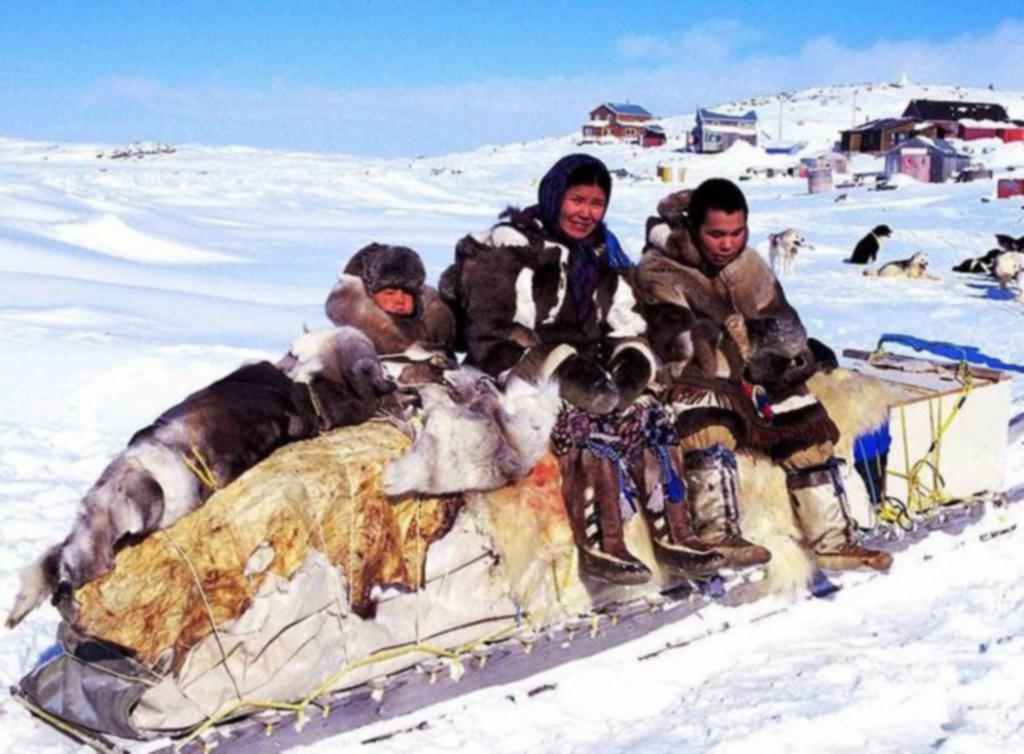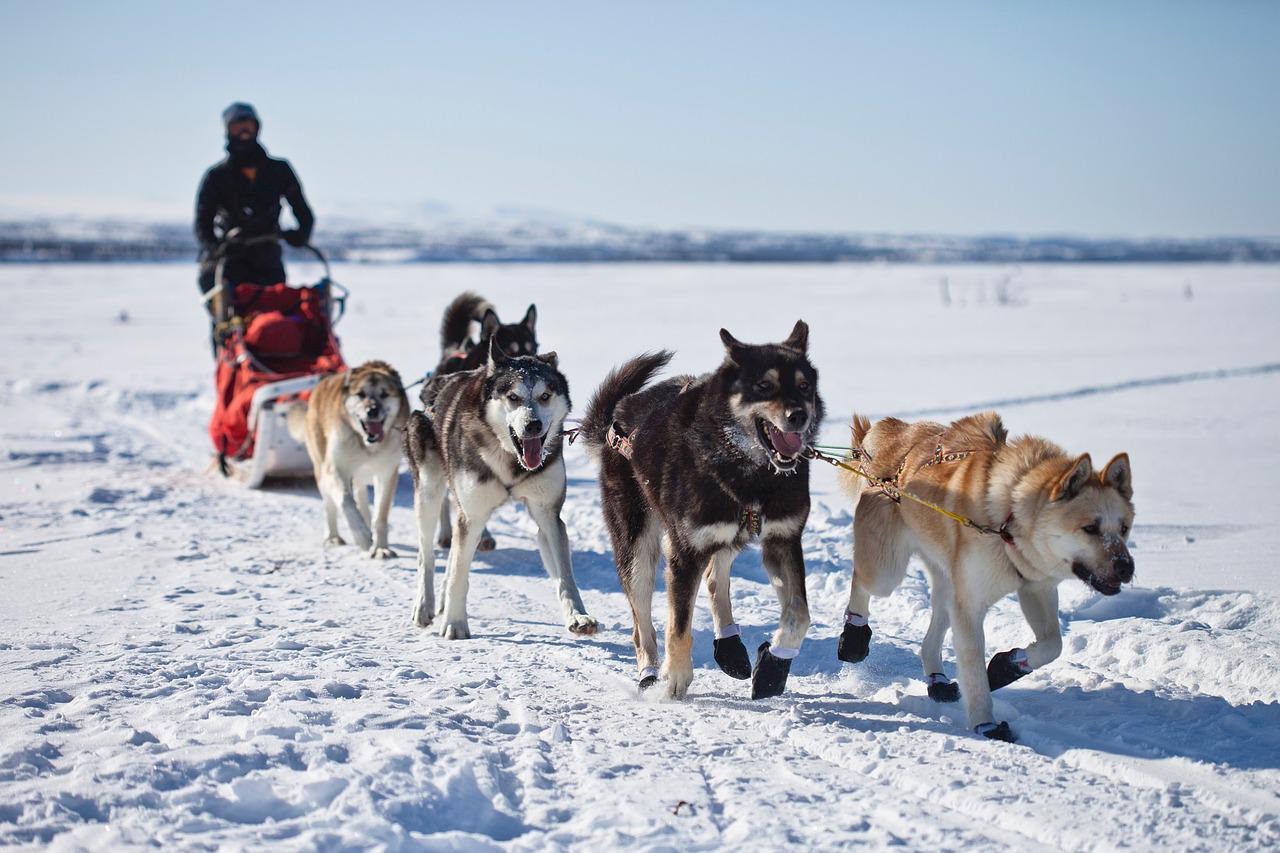The first image is the image on the left, the second image is the image on the right. Given the left and right images, does the statement "In the left image, dogs are moving forward." hold true? Answer yes or no. No. 